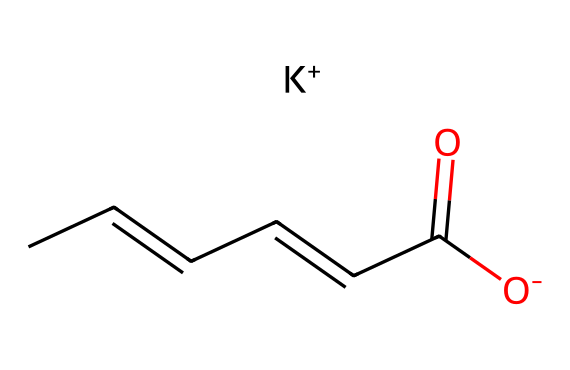how many carbon atoms are in potassium sorbate? By analyzing the SMILES representation, we can count the number of carbon (C) atoms present. In the structure "CC=CC=CC(=O)[O-]", there are six 'C' characters. Thus, there are six carbon atoms total.
Answer: six what is the functional group present in potassium sorbate? The SMILES notation shows a carboxylate group (C(=O)[O-]), which indicates that this compound contains a carboxylic acid functional group. This characteristic group is responsible for the chemical's preservative properties.
Answer: carboxylate how many double bonds are in potassium sorbate? In the given SMILES, we can observe multiple '=' signs that indicate double bonds. Upon inspection, there are three occurrences of double bonds (CC=CC=CC) in the structure.
Answer: three what type of compound is potassium sorbate classified as? Given that potassium sorbate is commonly used as a food preservative, and it’s based on the structure of a carboxylic acid, it is classified as a salt of a fatty acid derived from sorbic acid, now in its potassium form.
Answer: preservative what is the total number of oxygen atoms in potassium sorbate? From the SMILES structure, we can identify the number of oxygen (O) atoms present. The notation includes two 'O' characters, indicating that there are two oxygen atoms in total in this compound.
Answer: two what is the relationship between potassium sorbate and sorbic acid? Potassium sorbate is derived from sorbic acid. In terms of structure, sorbic acid is the acid form, while potassium sorbate is the potassium salt formed by neutralizing sorbic acid with potassium hydroxide. This relationship is fundamental to its classification as a preservative.
Answer: derivative 